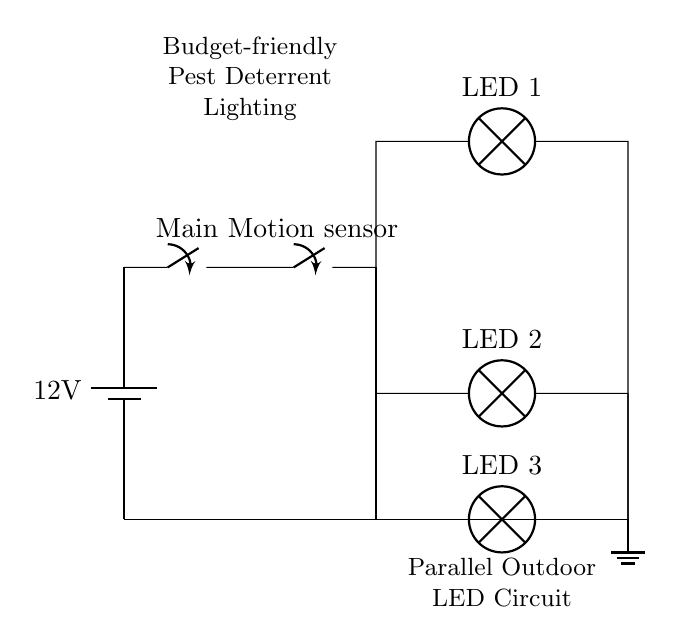What is the voltage of this circuit? The voltage is 12 volts, which is indicated by the battery symbol showing the power source.
Answer: 12 volts What type of switch is used for motion sensing? The circuit uses a switch labeled "Motion sensor," indicating that it activates the lights upon sensing motion.
Answer: Motion sensor How many LED lamps are present in the circuit? There are three LED lamps connected in parallel beneath the motion sensor switch, as shown by the three distinct branch paths leading to each lamp.
Answer: Three What is the function of the main switch in this circuit? The main switch connects or disconnects the entire circuit from the power source, allowing control over whether the circuits are powered.
Answer: Control power In a parallel circuit like this, what happens if one LED fails? If one LED fails, the remaining LEDs will still operate because they are connected in parallel, allowing current to bypass the malfunctioning component.
Answer: Remain operational What does the grounding symbol indicate in this circuit? The grounding symbol signifies the reference point for the circuit and ensures safe discharge of excess current, providing a path to earth.
Answer: Safety discharge What type of circuit is this setup considered? This setup is a parallel circuit, as indicated by the separate branches connecting to the same two points of the power source, providing independent paths for current.
Answer: Parallel circuit 